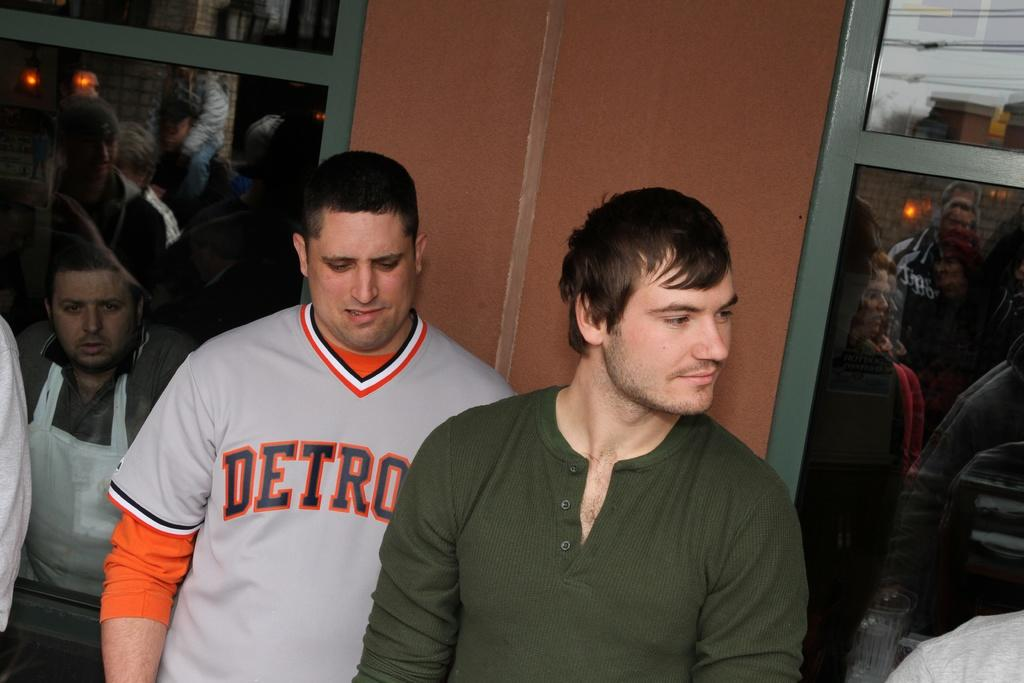<image>
Summarize the visual content of the image. Man wearing a grey Detroit jersey standing with another man. 